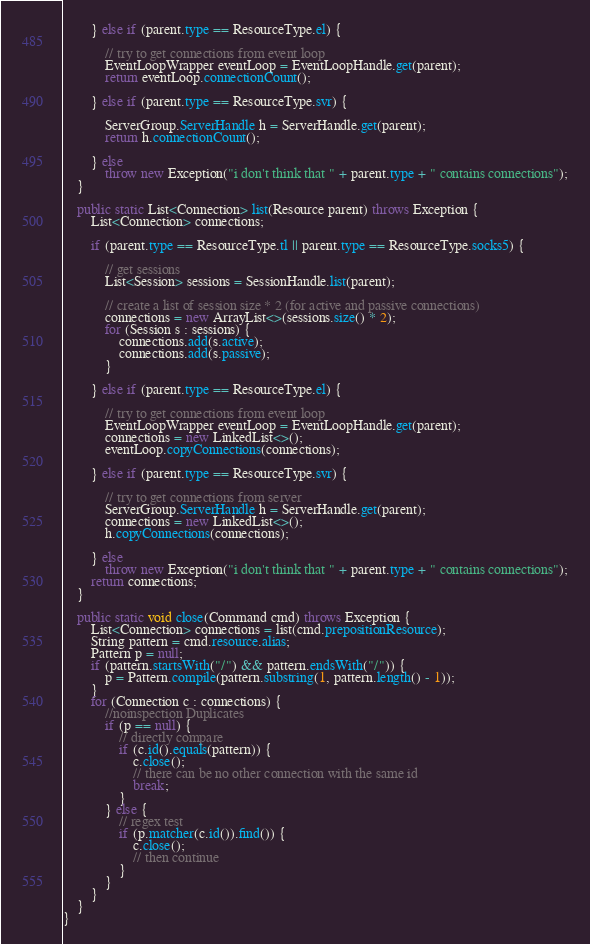Convert code to text. <code><loc_0><loc_0><loc_500><loc_500><_Java_>
        } else if (parent.type == ResourceType.el) {

            // try to get connections from event loop
            EventLoopWrapper eventLoop = EventLoopHandle.get(parent);
            return eventLoop.connectionCount();

        } else if (parent.type == ResourceType.svr) {

            ServerGroup.ServerHandle h = ServerHandle.get(parent);
            return h.connectionCount();

        } else
            throw new Exception("i don't think that " + parent.type + " contains connections");
    }

    public static List<Connection> list(Resource parent) throws Exception {
        List<Connection> connections;

        if (parent.type == ResourceType.tl || parent.type == ResourceType.socks5) {

            // get sessions
            List<Session> sessions = SessionHandle.list(parent);

            // create a list of session size * 2 (for active and passive connections)
            connections = new ArrayList<>(sessions.size() * 2);
            for (Session s : sessions) {
                connections.add(s.active);
                connections.add(s.passive);
            }

        } else if (parent.type == ResourceType.el) {

            // try to get connections from event loop
            EventLoopWrapper eventLoop = EventLoopHandle.get(parent);
            connections = new LinkedList<>();
            eventLoop.copyConnections(connections);

        } else if (parent.type == ResourceType.svr) {

            // try to get connections from server
            ServerGroup.ServerHandle h = ServerHandle.get(parent);
            connections = new LinkedList<>();
            h.copyConnections(connections);

        } else
            throw new Exception("i don't think that " + parent.type + " contains connections");
        return connections;
    }

    public static void close(Command cmd) throws Exception {
        List<Connection> connections = list(cmd.prepositionResource);
        String pattern = cmd.resource.alias;
        Pattern p = null;
        if (pattern.startsWith("/") && pattern.endsWith("/")) {
            p = Pattern.compile(pattern.substring(1, pattern.length() - 1));
        }
        for (Connection c : connections) {
            //noinspection Duplicates
            if (p == null) {
                // directly compare
                if (c.id().equals(pattern)) {
                    c.close();
                    // there can be no other connection with the same id
                    break;
                }
            } else {
                // regex test
                if (p.matcher(c.id()).find()) {
                    c.close();
                    // then continue
                }
            }
        }
    }
}
</code> 